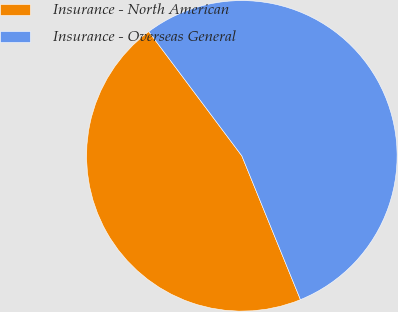Convert chart. <chart><loc_0><loc_0><loc_500><loc_500><pie_chart><fcel>Insurance - North American<fcel>Insurance - Overseas General<nl><fcel>45.93%<fcel>54.07%<nl></chart> 